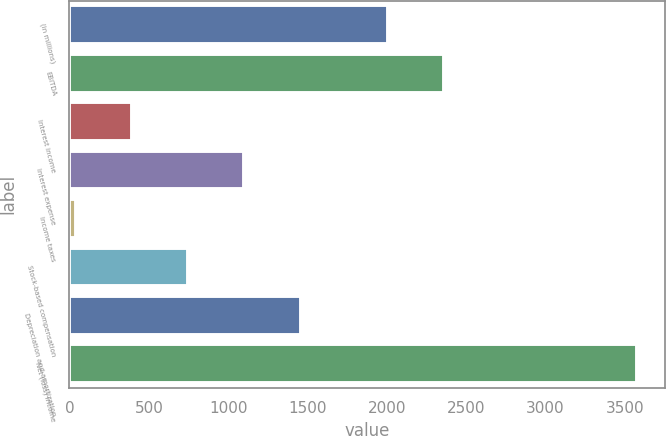Convert chart to OTSL. <chart><loc_0><loc_0><loc_500><loc_500><bar_chart><fcel>(in millions)<fcel>EBITDA<fcel>Interest income<fcel>Interest expense<fcel>Income taxes<fcel>Stock-based compensation<fcel>Depreciation and amortization<fcel>Net (loss) income<nl><fcel>2006<fcel>2359.5<fcel>395.5<fcel>1102.5<fcel>42<fcel>749<fcel>1456<fcel>3577<nl></chart> 